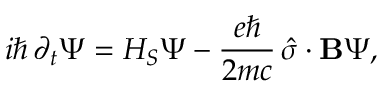Convert formula to latex. <formula><loc_0><loc_0><loc_500><loc_500>i \hbar { \, } \partial _ { t } \Psi = H _ { S } \Psi - { \frac { e } { 2 m c } } \, { \hat { \sigma } } \cdot B \Psi ,</formula> 